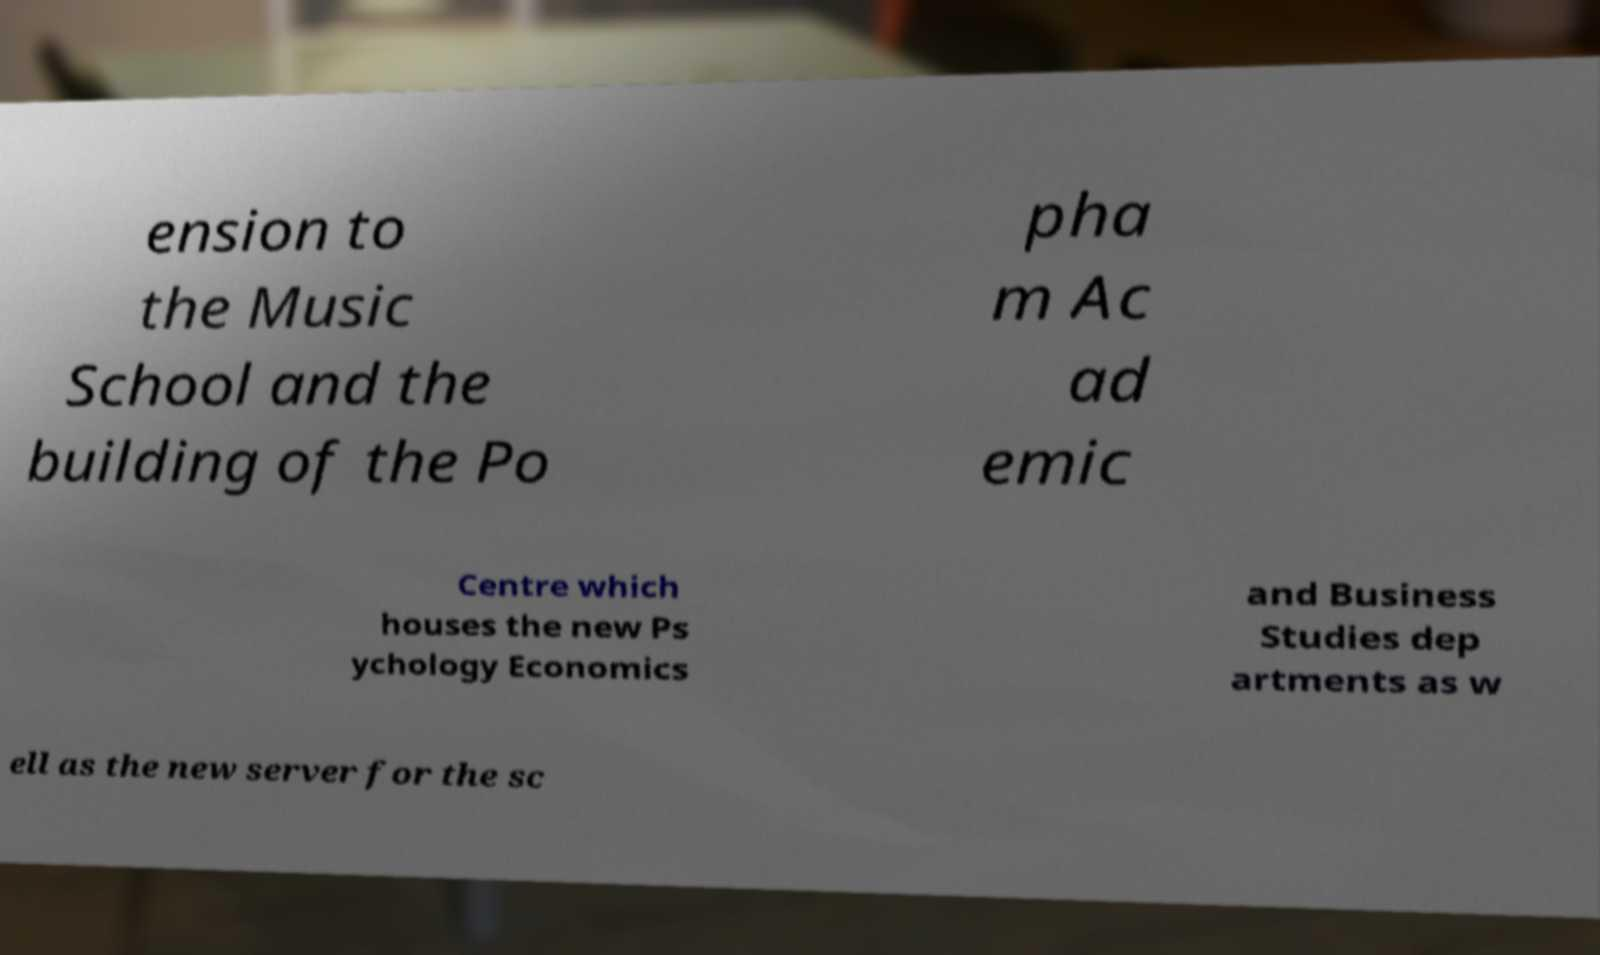Please identify and transcribe the text found in this image. ension to the Music School and the building of the Po pha m Ac ad emic Centre which houses the new Ps ychology Economics and Business Studies dep artments as w ell as the new server for the sc 